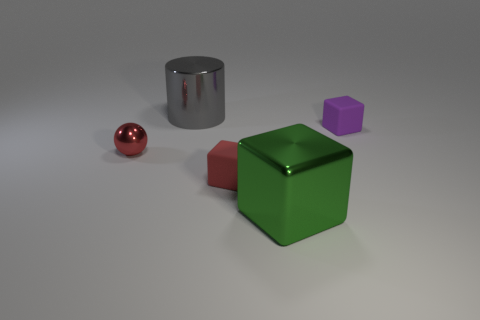The tiny shiny sphere has what color?
Your response must be concise. Red. How many other objects are the same shape as the purple thing?
Your answer should be very brief. 2. Is the number of red things left of the cylinder the same as the number of matte cubes in front of the tiny red matte thing?
Make the answer very short. No. What is the large green cube made of?
Give a very brief answer. Metal. There is a tiny red object to the right of the red shiny object; what is it made of?
Ensure brevity in your answer.  Rubber. Are there any other things that have the same material as the small red block?
Ensure brevity in your answer.  Yes. Are there more small red blocks that are behind the red metallic thing than small yellow shiny objects?
Offer a very short reply. No. Is there a large gray shiny cylinder right of the tiny matte object that is behind the tiny object in front of the red metallic ball?
Provide a short and direct response. No. There is a small sphere; are there any balls in front of it?
Provide a short and direct response. No. What number of large cubes are the same color as the large metallic cylinder?
Make the answer very short. 0. 